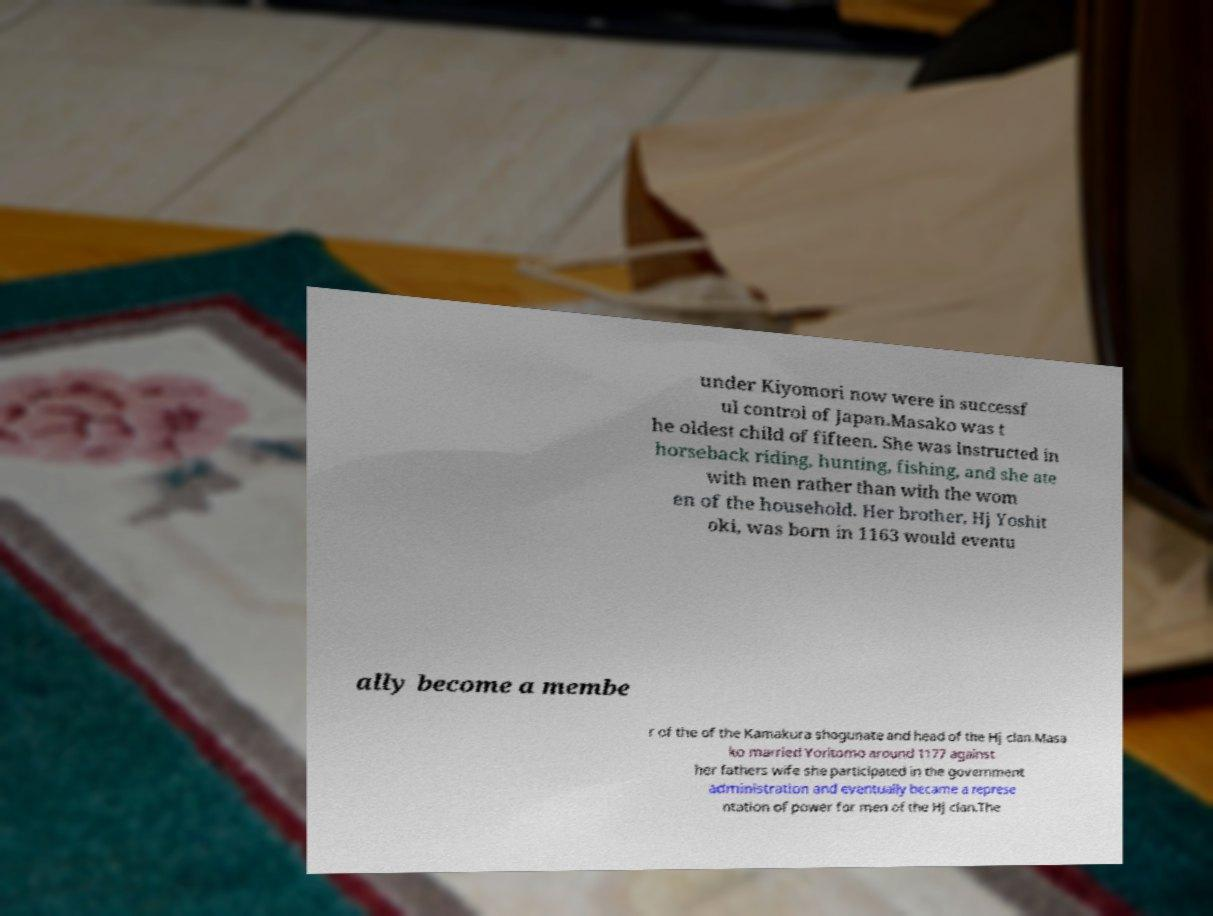For documentation purposes, I need the text within this image transcribed. Could you provide that? under Kiyomori now were in successf ul control of Japan.Masako was t he oldest child of fifteen. She was instructed in horseback riding, hunting, fishing, and she ate with men rather than with the wom en of the household. Her brother, Hj Yoshit oki, was born in 1163 would eventu ally become a membe r of the of the Kamakura shogunate and head of the Hj clan.Masa ko married Yoritomo around 1177 against her fathers wife she participated in the government administration and eventually became a represe ntation of power for men of the Hj clan.The 